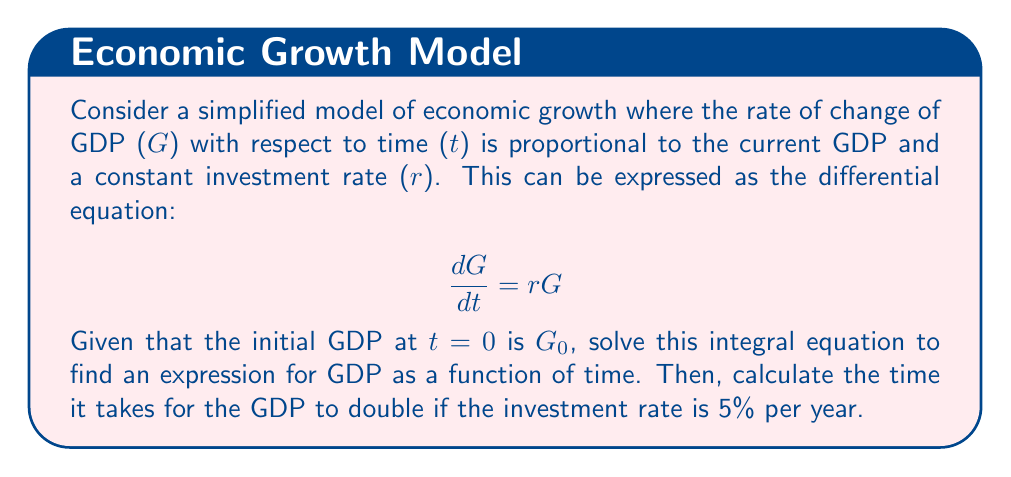Give your solution to this math problem. 1) First, we need to solve the differential equation. We can rewrite it as:

   $$\frac{dG}{G} = r dt$$

2) Integrating both sides:

   $$\int \frac{dG}{G} = \int r dt$$

3) This gives us:

   $$\ln|G| = rt + C$$

   where C is a constant of integration.

4) Taking the exponential of both sides:

   $$G = e^{rt + C} = e^C \cdot e^{rt}$$

5) At t=0, G = $G_0$, so:

   $$G_0 = e^C$$

6) Therefore, our solution is:

   $$G(t) = G_0 e^{rt}$$

7) To find the time it takes for GDP to double, we set:

   $$2G_0 = G_0 e^{rt}$$

8) Simplifying:

   $$2 = e^{rt}$$

9) Taking the natural log of both sides:

   $$\ln 2 = rt$$

10) Solving for t:

    $$t = \frac{\ln 2}{r}$$

11) Given r = 5% = 0.05, we can calculate:

    $$t = \frac{\ln 2}{0.05} \approx 13.86\text{ years}$$
Answer: $G(t) = G_0 e^{rt}$; 13.86 years to double 